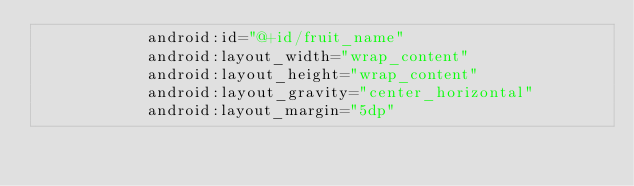Convert code to text. <code><loc_0><loc_0><loc_500><loc_500><_XML_>            android:id="@+id/fruit_name"
            android:layout_width="wrap_content"
            android:layout_height="wrap_content"
            android:layout_gravity="center_horizontal"
            android:layout_margin="5dp"</code> 